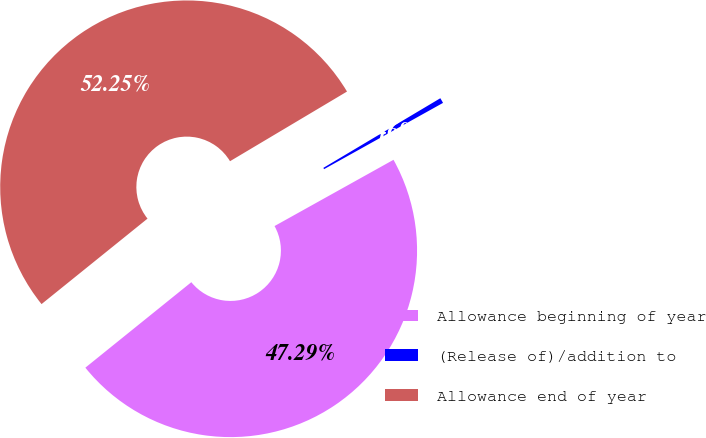Convert chart. <chart><loc_0><loc_0><loc_500><loc_500><pie_chart><fcel>Allowance beginning of year<fcel>(Release of)/addition to<fcel>Allowance end of year<nl><fcel>47.29%<fcel>0.46%<fcel>52.26%<nl></chart> 